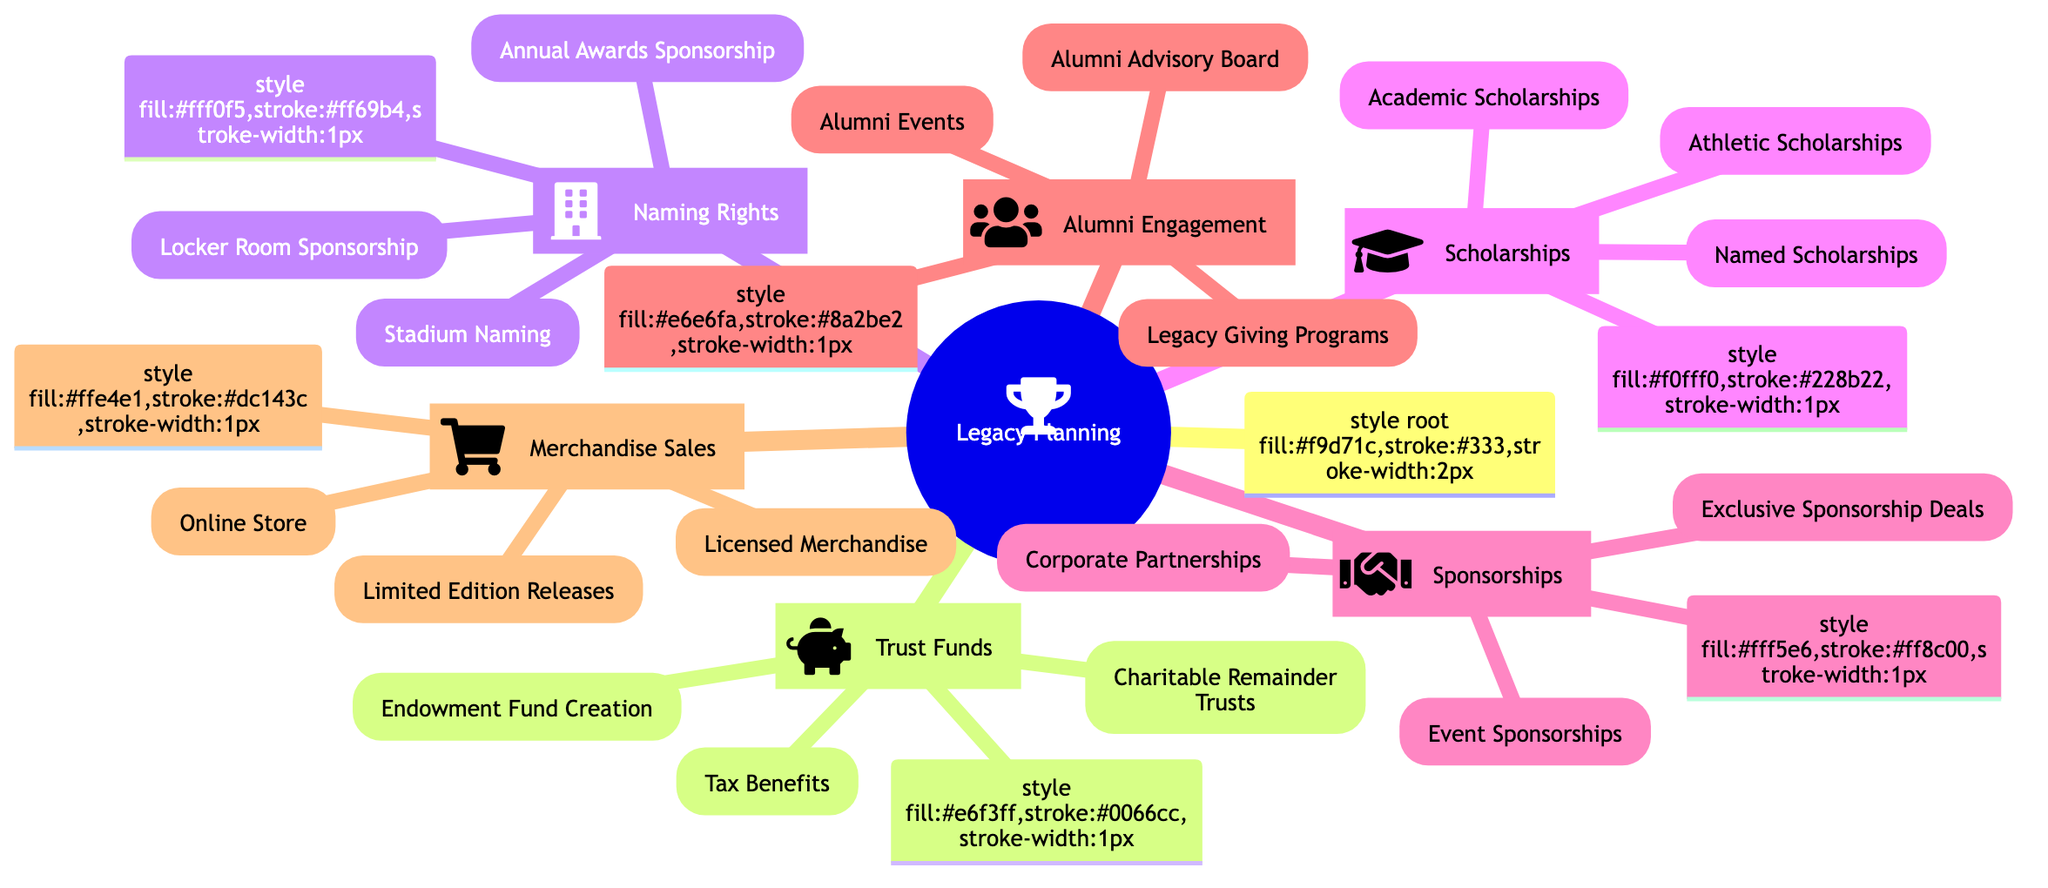What are the different categories under Legacy Planning? The main categories under Legacy Planning in the diagram are Trust Funds, Naming Rights, Scholarships, Sponsorships, Alumni Engagement, and Merchandise Sales. These categories can be found as the first level of branches directly connected to the central node.
Answer: Trust Funds, Naming Rights, Scholarships, Sponsorships, Alumni Engagement, Merchandise Sales How many elements are listed under Trust Funds? In the Trust Funds branch, there are three elements: Endowment Fund Creation, Charitable Remainder Trusts, and Tax Benefits. By counting these elements, we find the total number of items present.
Answer: 3 What elements are included in Alumni Engagement? The Alumni Engagement category includes three elements, which are Alumni Events, Alumni Advisory Board, and Legacy Giving Programs. These elements are directly listed under the Alumni Engagement node.
Answer: Alumni Events, Alumni Advisory Board, Legacy Giving Programs Which category focuses on generating revenue through merchandise? The category that focuses on generating revenue through merchandise is Merchandise Sales. This can be seen directly linked as a branch under Legacy Planning.
Answer: Merchandise Sales What is the primary purpose of Scholarships in the context of Legacy Planning? The primary purpose of Scholarships as described in the diagram is to help with recruitment and retention of athletes. This description can be found in the subtext of the Scholarships node.
Answer: Help with recruitment and retention Which category connects to long-term financial support and has sub-elements about sponsorships? The category that connects to long-term financial support and discusses sponsorships is Sponsorships. This can be identified as a main branch that outlines detailed sub-elements related to corporate and event sponsorships.
Answer: Sponsorships What type of sponsorship deals are mentioned under Sponsorships? The types of sponsorship deals mentioned under Sponsorships are Corporate Partnerships, Exclusive Sponsorship Deals, and Event Sponsorships. These are explicitly listed as the elements in that category.
Answer: Corporate Partnerships, Exclusive Sponsorship Deals, Event Sponsorships How is Naming Rights intended to help in Legacy Planning? Naming Rights is intended to help in Legacy Planning by generating revenue through securing naming rights for stadiums, facilities, or events. This insight is derived from the description connected to the Naming Rights branch.
Answer: Generate revenue What benefits are associated with Trust Funds according to the diagram? The benefits associated with Trust Funds include Endowment Fund Creation, Charitable Remainder Trusts, and Tax Benefits. These are the specific elements listed under the Trust Funds category in the diagram.
Answer: Endowment Fund Creation, Charitable Remainder Trusts, Tax Benefits 